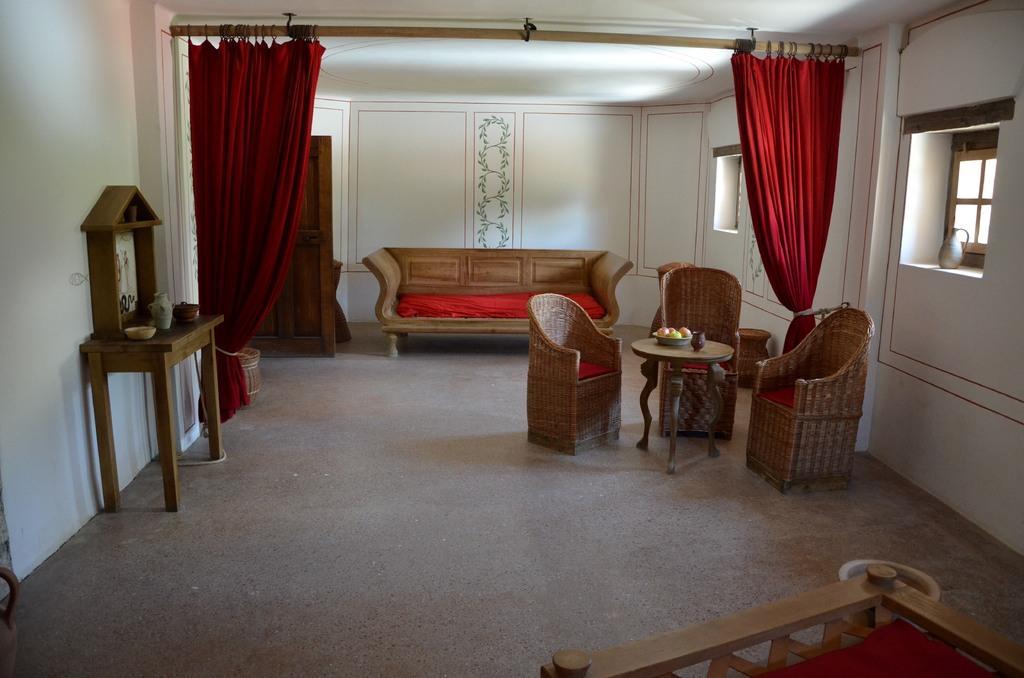Could you give a brief overview of what you see in this image? this is a room in this room we can see couch and chairs in between the chairs there is a table on that table there is a fruit bowl there is a cloth angle there is a window right side of the image and we have a bed. 